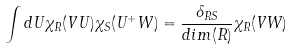Convert formula to latex. <formula><loc_0><loc_0><loc_500><loc_500>\int d U \chi _ { R } ( V U ) \chi _ { S } ( U ^ { + } W ) = \frac { \delta _ { R S } } { d i m ( R ) } \chi _ { R } ( V W )</formula> 